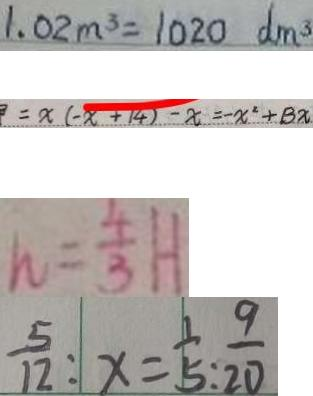Convert formula to latex. <formula><loc_0><loc_0><loc_500><loc_500>1 . 0 2 m ^ { 3 } = 1 0 2 0 d m ^ { 3 } 
 = x ( - x + 1 4 ) - x = - x ^ { 2 } + B x 
 h = \frac { 4 } { 3 } H 
 \frac { 5 } { 1 2 } : x = \frac { 1 } { 5 } : \frac { 9 } { 2 0 }</formula> 